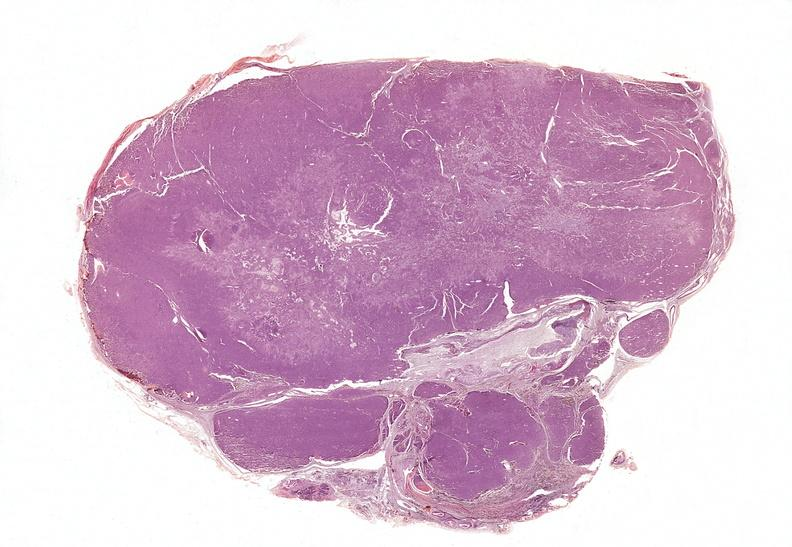does this image show parathyroid, adenoma, functional?
Answer the question using a single word or phrase. Yes 